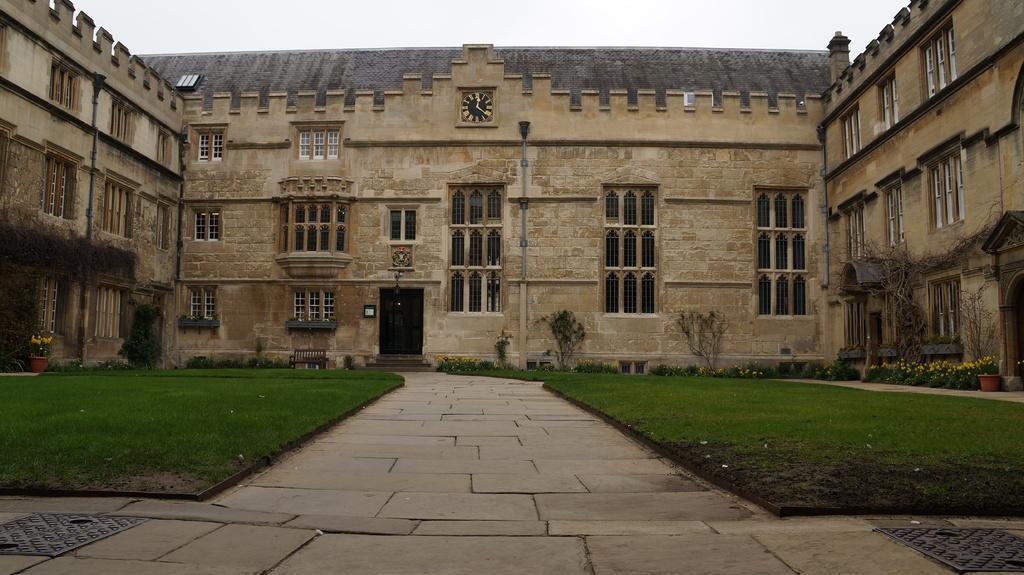Please provide a concise description of this image. In this picture we can see manholes on the ground, here we can see trees, house plants with flowers, plants, grass, bench and in the background we can see a building, sky. 